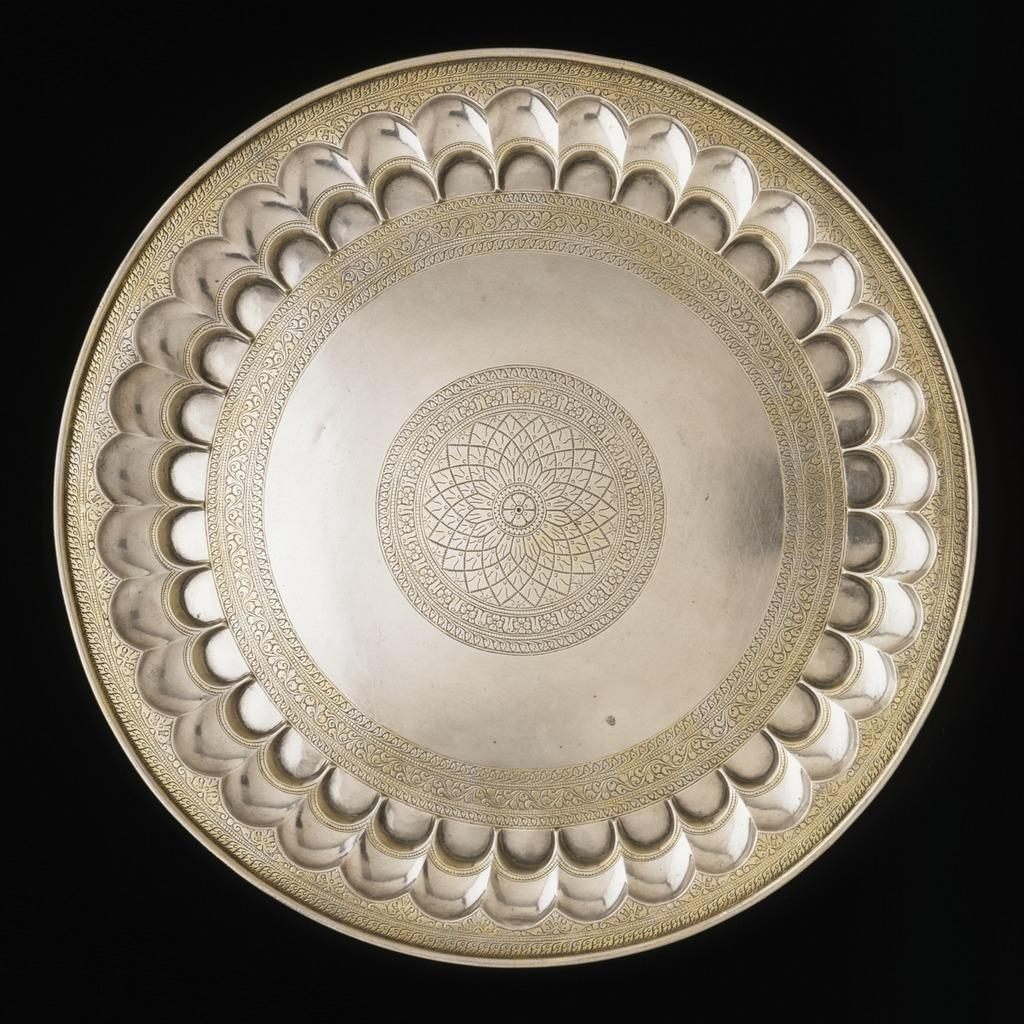What object can be seen in the image? There is a plate in the image. How many clovers are growing on the floor in the image? There is no mention of clovers or a floor in the image; it only features a plate. 